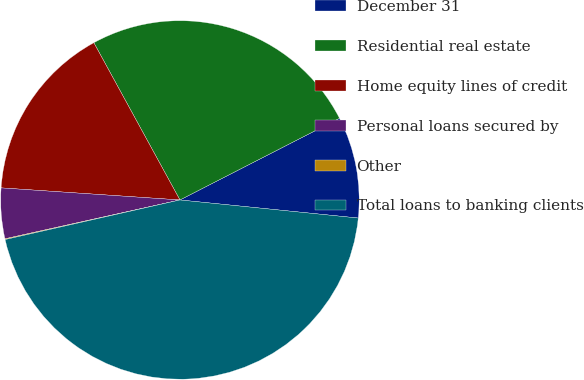<chart> <loc_0><loc_0><loc_500><loc_500><pie_chart><fcel>December 31<fcel>Residential real estate<fcel>Home equity lines of credit<fcel>Personal loans secured by<fcel>Other<fcel>Total loans to banking clients<nl><fcel>9.14%<fcel>25.44%<fcel>15.95%<fcel>4.55%<fcel>0.07%<fcel>44.84%<nl></chart> 